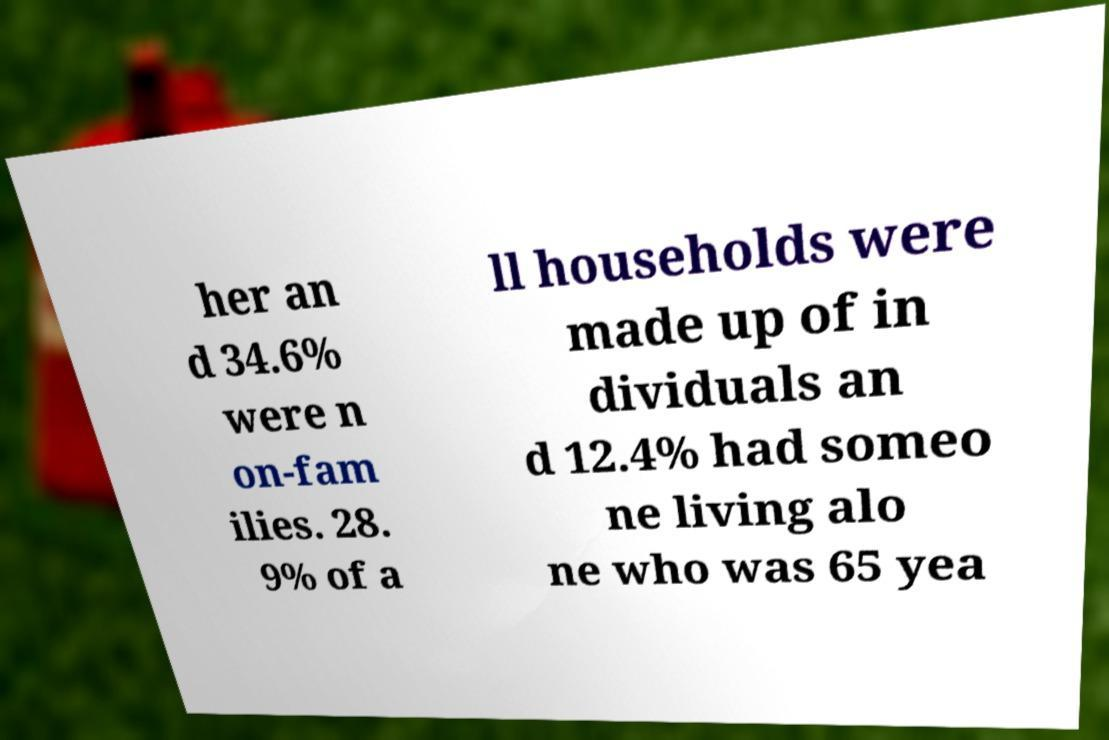Can you read and provide the text displayed in the image?This photo seems to have some interesting text. Can you extract and type it out for me? her an d 34.6% were n on-fam ilies. 28. 9% of a ll households were made up of in dividuals an d 12.4% had someo ne living alo ne who was 65 yea 